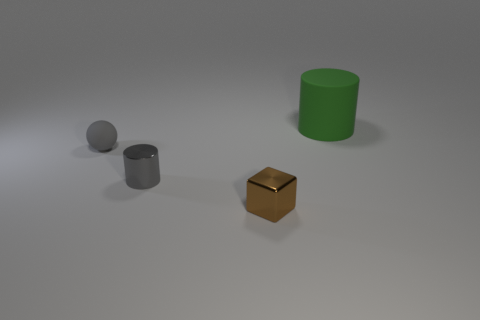Are there more gray metallic cylinders to the right of the matte cylinder than gray metallic cylinders?
Ensure brevity in your answer.  No. What number of other metallic cylinders have the same size as the metal cylinder?
Make the answer very short. 0. Does the cylinder that is on the left side of the big green rubber object have the same size as the cylinder that is right of the tiny brown cube?
Provide a succinct answer. No. There is a matte object right of the small gray cylinder; what is its size?
Give a very brief answer. Large. What is the size of the matte thing to the right of the matte object on the left side of the green rubber cylinder?
Ensure brevity in your answer.  Large. There is a cylinder that is the same size as the sphere; what material is it?
Make the answer very short. Metal. Are there any gray objects on the left side of the gray matte thing?
Your response must be concise. No. Are there an equal number of rubber things that are in front of the tiny brown block and green rubber blocks?
Provide a short and direct response. Yes. What is the shape of the brown thing that is the same size as the gray rubber thing?
Offer a very short reply. Cube. What material is the green cylinder?
Your answer should be very brief. Rubber. 